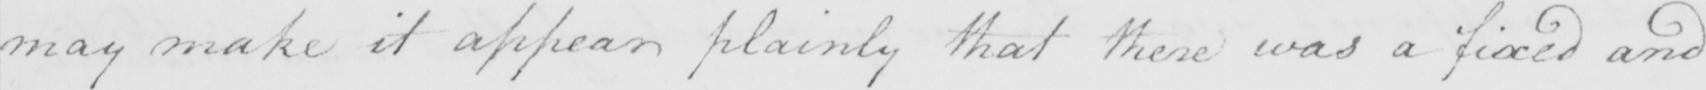What is written in this line of handwriting? may make it appear plainly that there was a fixed and 